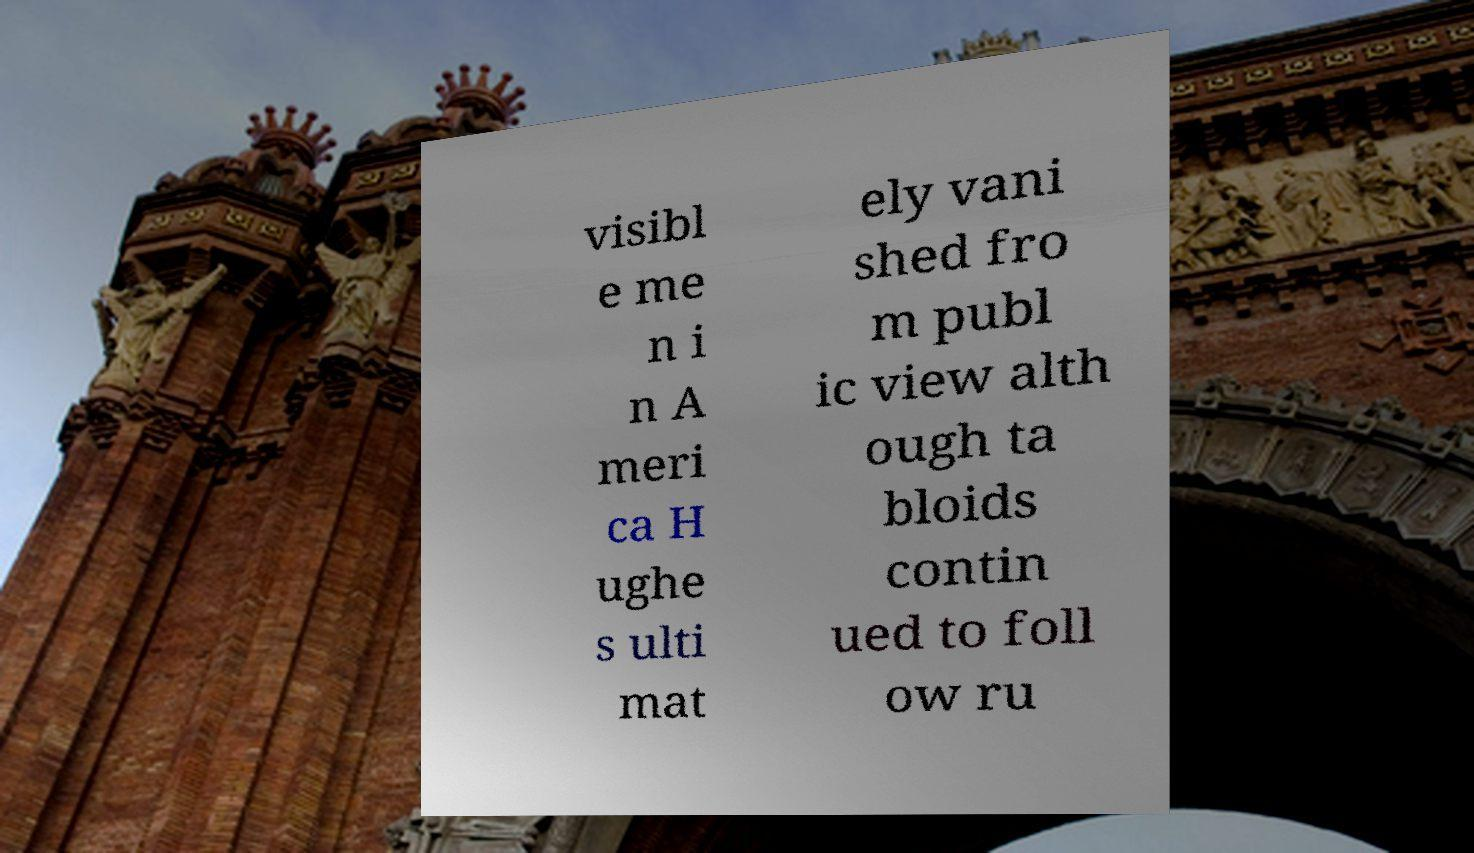Can you read and provide the text displayed in the image?This photo seems to have some interesting text. Can you extract and type it out for me? visibl e me n i n A meri ca H ughe s ulti mat ely vani shed fro m publ ic view alth ough ta bloids contin ued to foll ow ru 